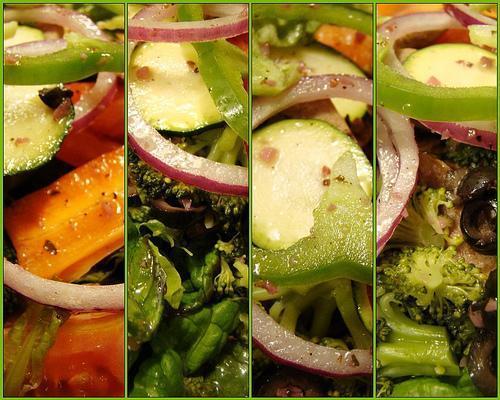How many picture scenes are there?
Give a very brief answer. 4. 